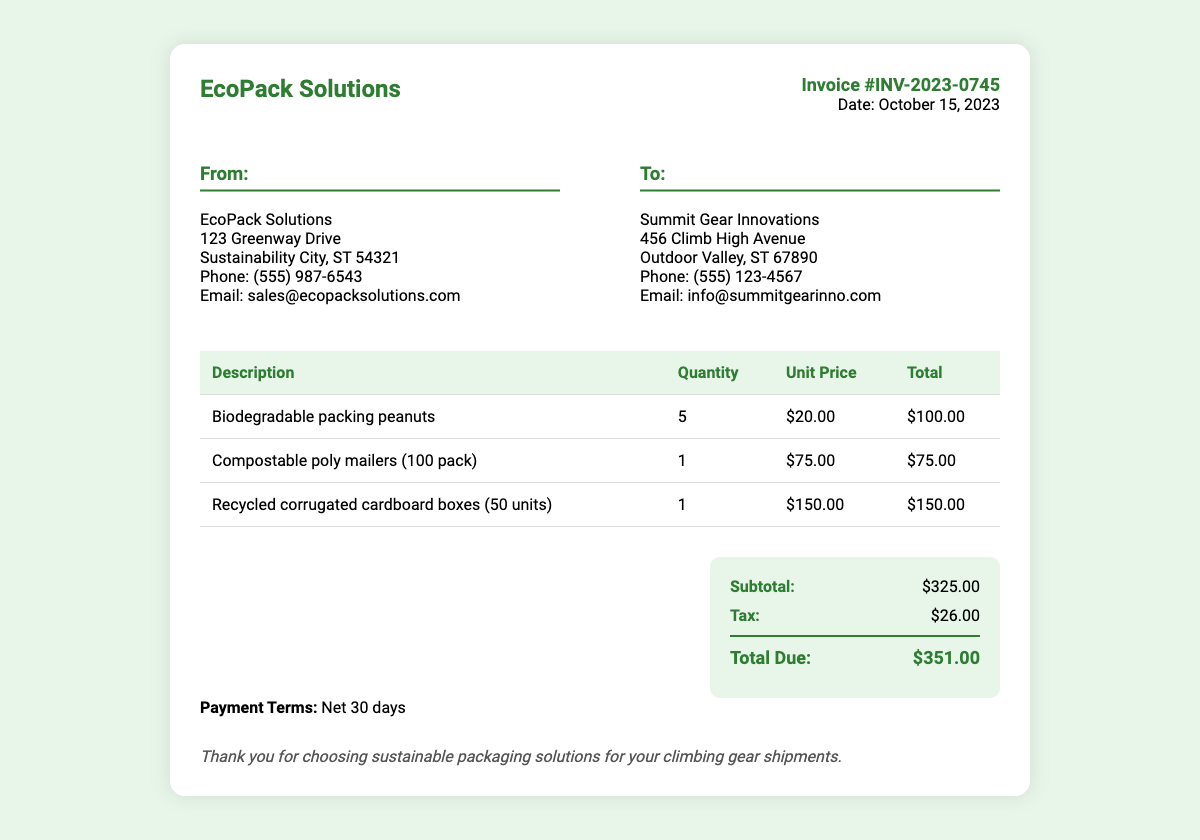What is the invoice number? The invoice number is provided in the header section of the document as a unique identifier for the transaction.
Answer: INV-2023-0745 What is the date of the invoice? The invoice date can be found in the invoice details section, indicating when the invoice was issued.
Answer: October 15, 2023 Who is the supplier? The supplier's name is listed in the "From" section of the invoice, indicating the company that issued the invoice.
Answer: EcoPack Solutions What is the quantity of biodegradable packing peanuts purchased? The quantity refers to the number of items ordered, which is detailed in the itemized list of supplies on the invoice.
Answer: 5 What is the total due amount? The total due amount is calculated from the subtotal and tax, shown distinctly in the total section of the invoice.
Answer: $351.00 How much is the subtotal before tax? The subtotal represents the total cost of items before any tax is applied, as indicated in the total section of the invoice.
Answer: $325.00 What type of mailers were purchased? The type of mailers can be identified in the itemized table detailing the items ordered in the transaction.
Answer: Compostable poly mailers What is the tax amount? The tax amount is listed next to the subtotal in the total section, representing the applicable tax charge.
Answer: $26.00 What is the payment term specified in the invoice? The payment terms indicate how long the buyer has to make the payment after receiving the invoice, mentioned at the bottom of the document.
Answer: Net 30 days 